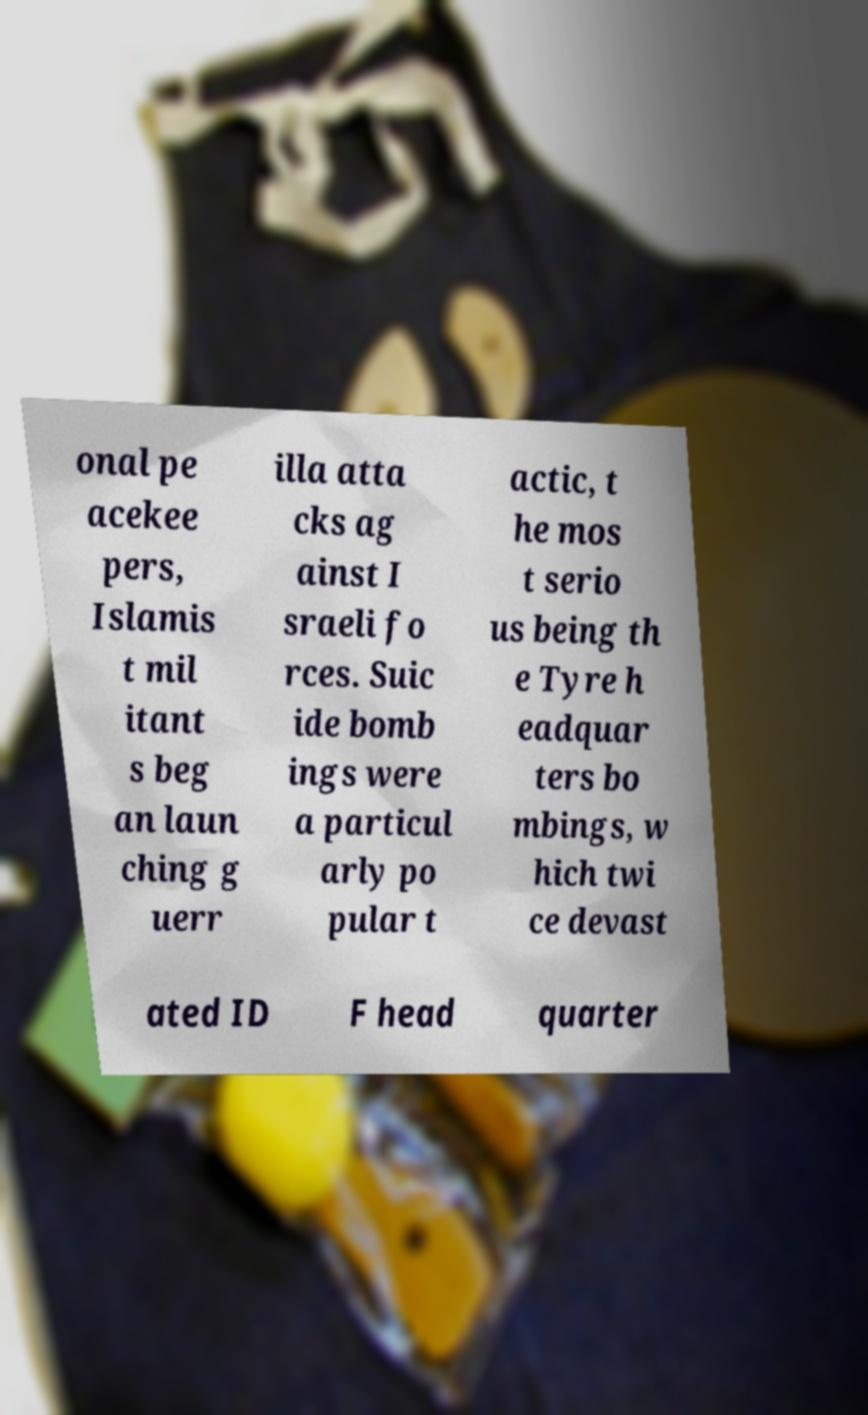Could you assist in decoding the text presented in this image and type it out clearly? onal pe acekee pers, Islamis t mil itant s beg an laun ching g uerr illa atta cks ag ainst I sraeli fo rces. Suic ide bomb ings were a particul arly po pular t actic, t he mos t serio us being th e Tyre h eadquar ters bo mbings, w hich twi ce devast ated ID F head quarter 